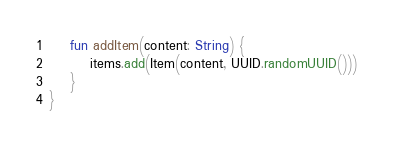Convert code to text. <code><loc_0><loc_0><loc_500><loc_500><_Kotlin_>
	fun addItem(content: String) {
		items.add(Item(content, UUID.randomUUID()))
	}
}
</code> 